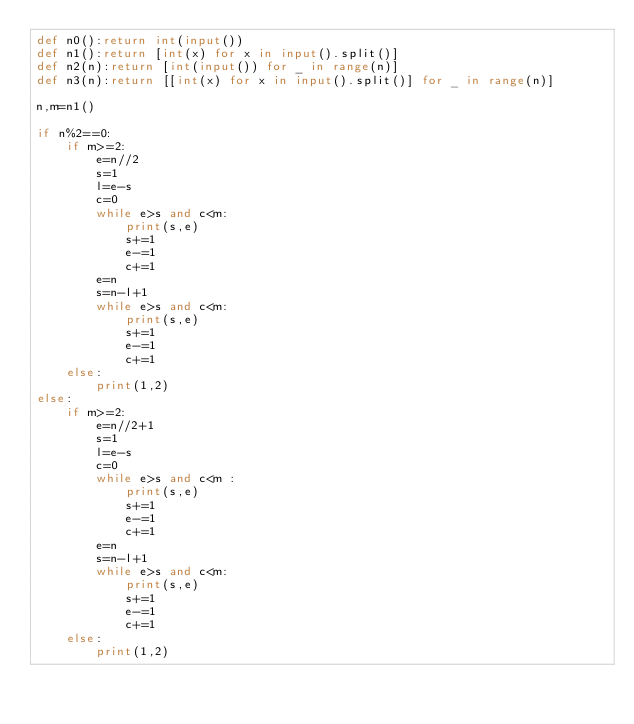<code> <loc_0><loc_0><loc_500><loc_500><_Python_>def n0():return int(input())
def n1():return [int(x) for x in input().split()]
def n2(n):return [int(input()) for _ in range(n)]
def n3(n):return [[int(x) for x in input().split()] for _ in range(n)]

n,m=n1()

if n%2==0:
    if m>=2:
        e=n//2
        s=1
        l=e-s
        c=0
        while e>s and c<m:
            print(s,e)
            s+=1
            e-=1
            c+=1
        e=n
        s=n-l+1
        while e>s and c<m:
            print(s,e)
            s+=1
            e-=1
            c+=1
    else:
        print(1,2)
else:
    if m>=2:
        e=n//2+1
        s=1
        l=e-s
        c=0
        while e>s and c<m :
            print(s,e)
            s+=1
            e-=1
            c+=1
        e=n
        s=n-l+1
        while e>s and c<m:
            print(s,e)
            s+=1
            e-=1
            c+=1
    else:
        print(1,2)</code> 